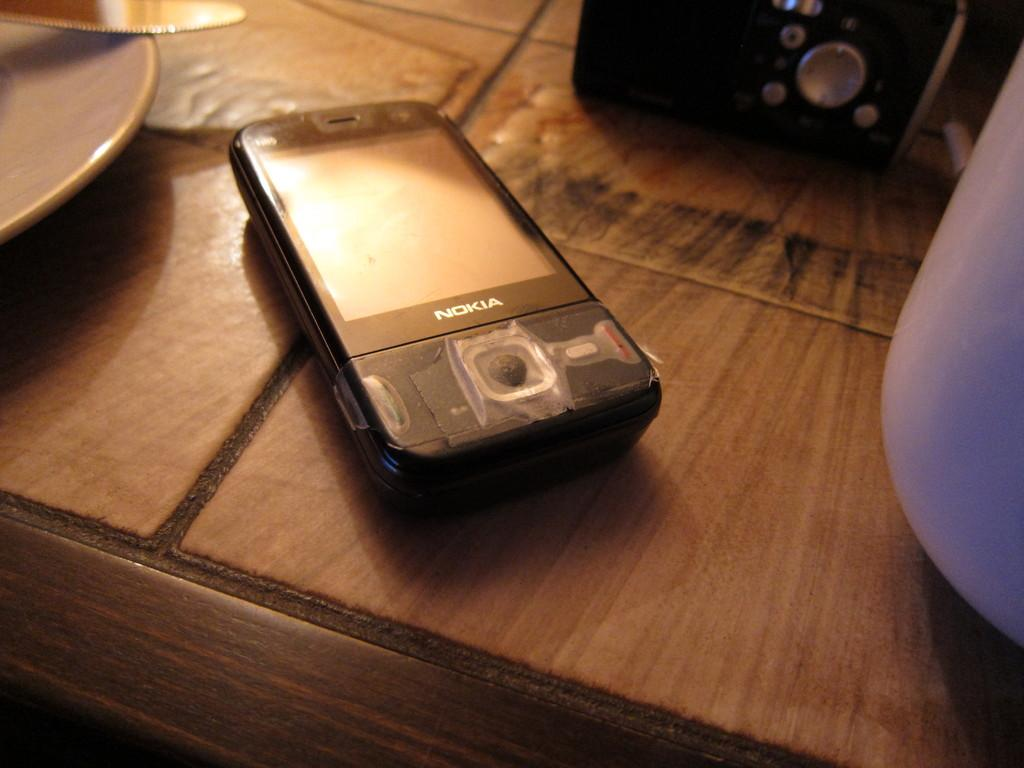<image>
Relay a brief, clear account of the picture shown. an old NOKIA phone sitting on a desk top 